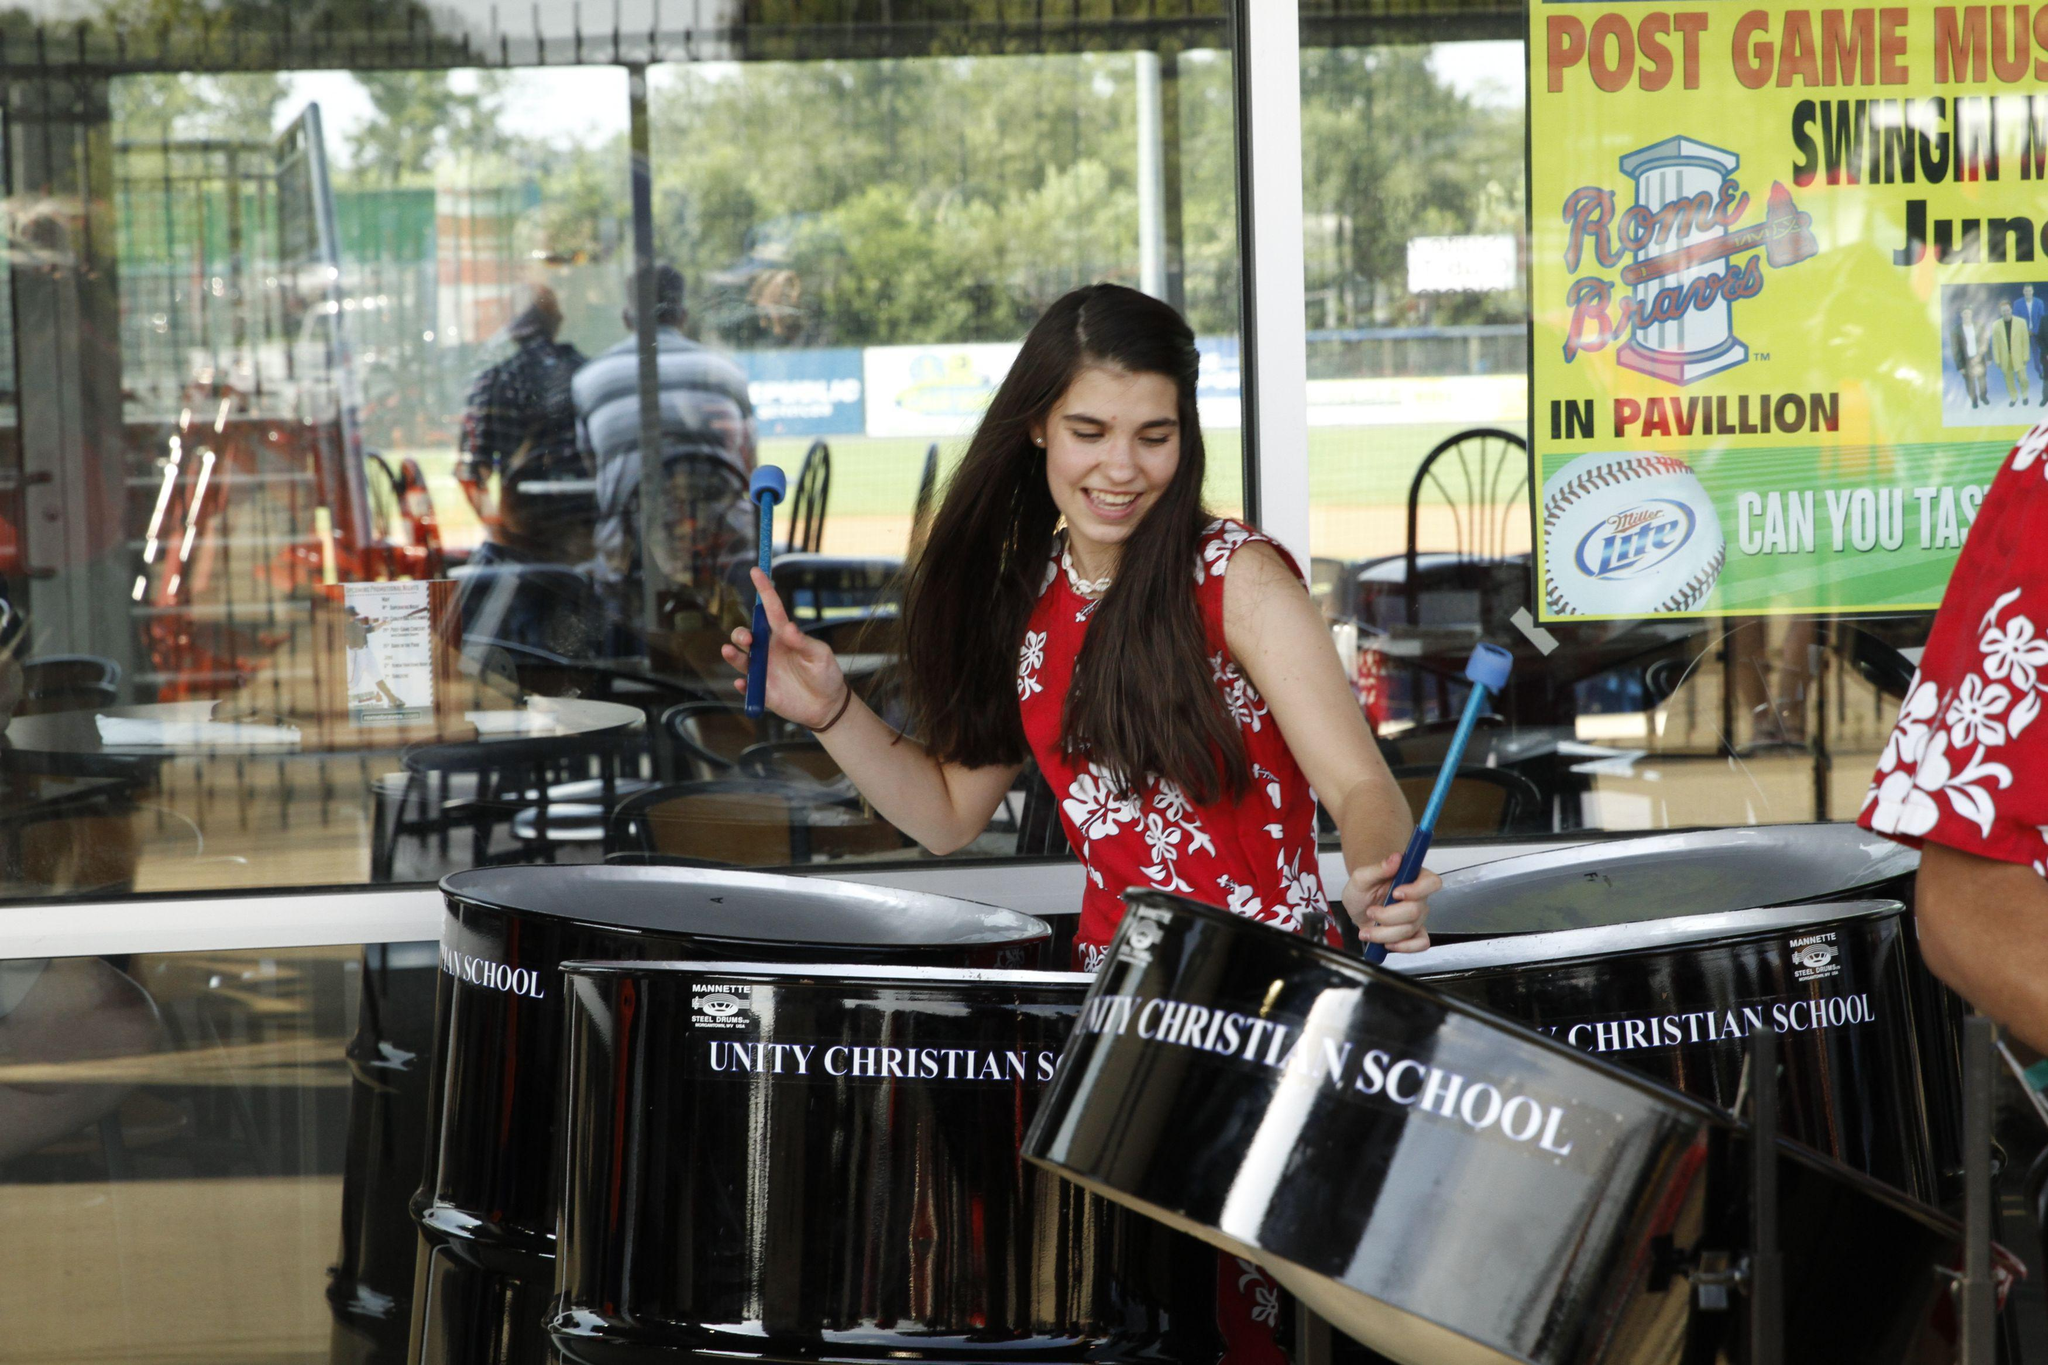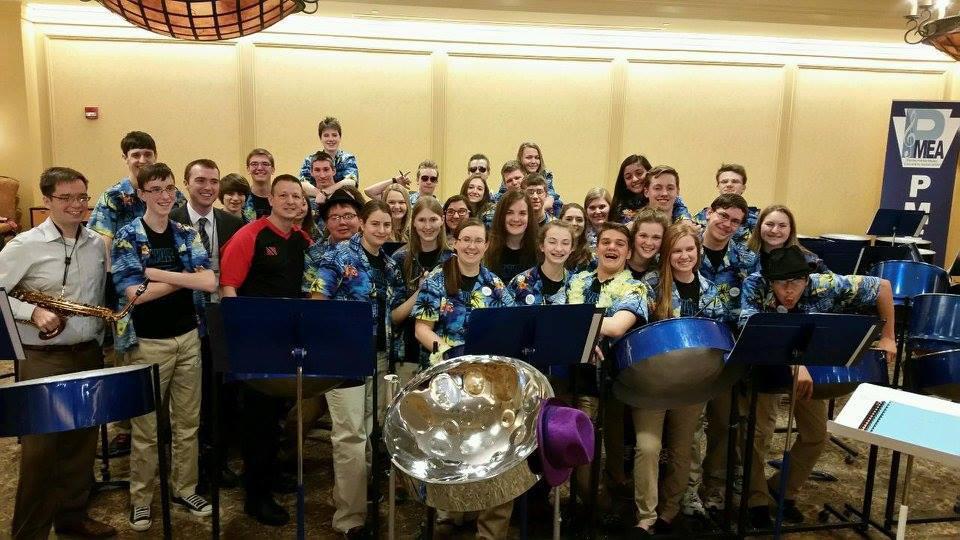The first image is the image on the left, the second image is the image on the right. For the images displayed, is the sentence "In at least one image there are at least three women of color playing a fully metal drum." factually correct? Answer yes or no. No. 